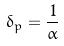<formula> <loc_0><loc_0><loc_500><loc_500>\delta _ { p } = \frac { 1 } { \alpha }</formula> 